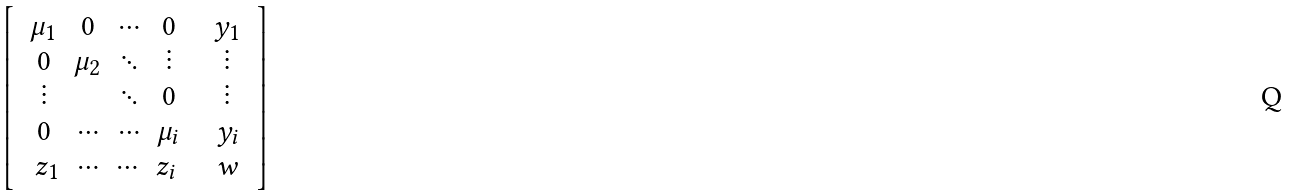<formula> <loc_0><loc_0><loc_500><loc_500>\left [ \begin{array} { c c } \begin{array} { c c c c } \mu _ { 1 } & 0 & \cdots & 0 \\ 0 & \mu _ { 2 } & \ddots & \vdots \\ \vdots & \, & \ddots & 0 \\ 0 & \cdots & \cdots & \mu _ { i } \\ \end{array} & \begin{array} { c } y _ { 1 } \\ \vdots \\ \vdots \\ y _ { i } \end{array} \\ \begin{array} { c c c c } z _ { 1 } & \cdots & \cdots & z _ { i } \end{array} & w \end{array} \right ]</formula> 